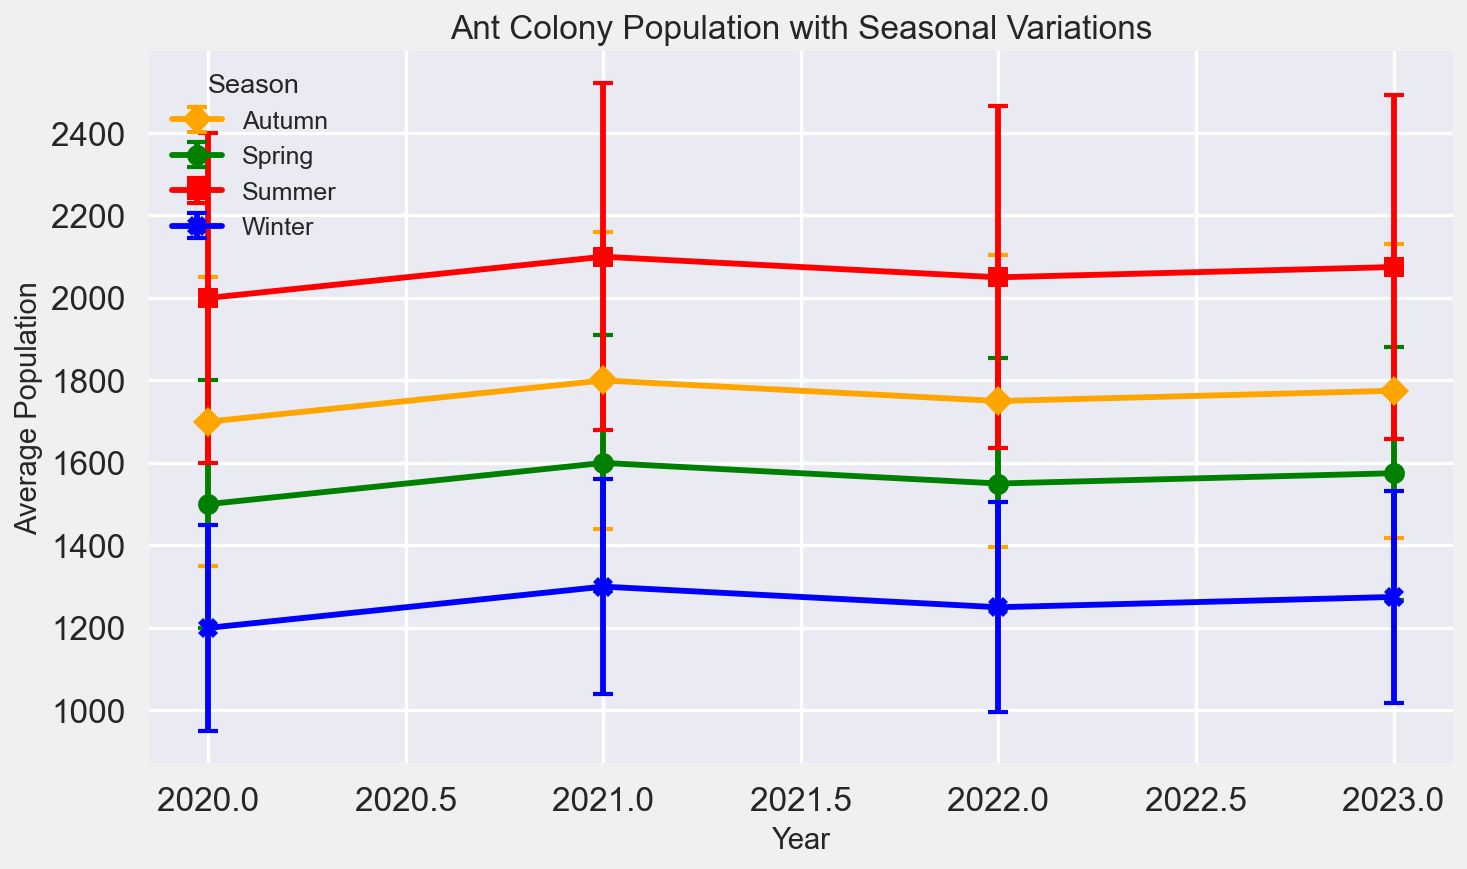What season had the highest average population in 2021? Look at the data for 2021 and compare the average populations for each season. Summer has the highest value.
Answer: Summer What is the difference in average population between Summer and Winter in 2020? Look at the average population for Summer in 2020 (2000) and Winter in 2020 (1200). Subtract the Winter population from the Summer population: 2000 - 1200.
Answer: 800 Which season shows a consistent rise in average population every year from 2020 to 2023? Compare the average population values for each season across the years. The Spring season shows a rising trend: 1500 (2020), 1600 (2021), 1550 (2022), 1575 (2023).
Answer: Spring What is the range of average populations for Autumn over the years displayed? Identify the highest and lowest average population values for Autumn: the minimum is 1700 in 2020 and the maximum is 1800 in 2021. Calculate the range: 1800 - 1700.
Answer: 100 Which season has the smallest standard deviation in 2023? Look at the standard deviations for each season in 2023: Spring (307), Summer (417), Autumn (357), Winter (257). Winter has the smallest standard deviation.
Answer: Winter How does the average population in Summer 2023 compare to Autumn 2021? Identify the average population in Summer 2023 (2075) and in Autumn 2021 (1800). Compare them: 2075 - 1800.
Answer: 275 more What are the colors used to represent each season in the graph? Observe the legend of the plot. Spring is green, Summer is red, Autumn is orange, and Winter is blue.
Answer: Spring: green, Summer: red, Autumn: orange, Winter: blue In which year did the Winter season have the lowest average population? Compare the Winter average populations across the years: 1200 (2020), 1300 (2021), 1250 (2022), 1275 (2023). The lowest is 1200 in 2020.
Answer: 2020 Which season has the highest fluctuation in population over the years 2020 to 2023, based on standard deviation? Compare the standard deviation values for each season over the years. Summer has the highest standard deviations: 400 (2020), 420 (2021), 415 (2022), 417 (2023).
Answer: Summer 